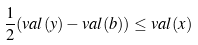<formula> <loc_0><loc_0><loc_500><loc_500>\frac { 1 } { 2 } ( v a l ( y ) - v a l ( b ) ) \leq v a l ( x )</formula> 